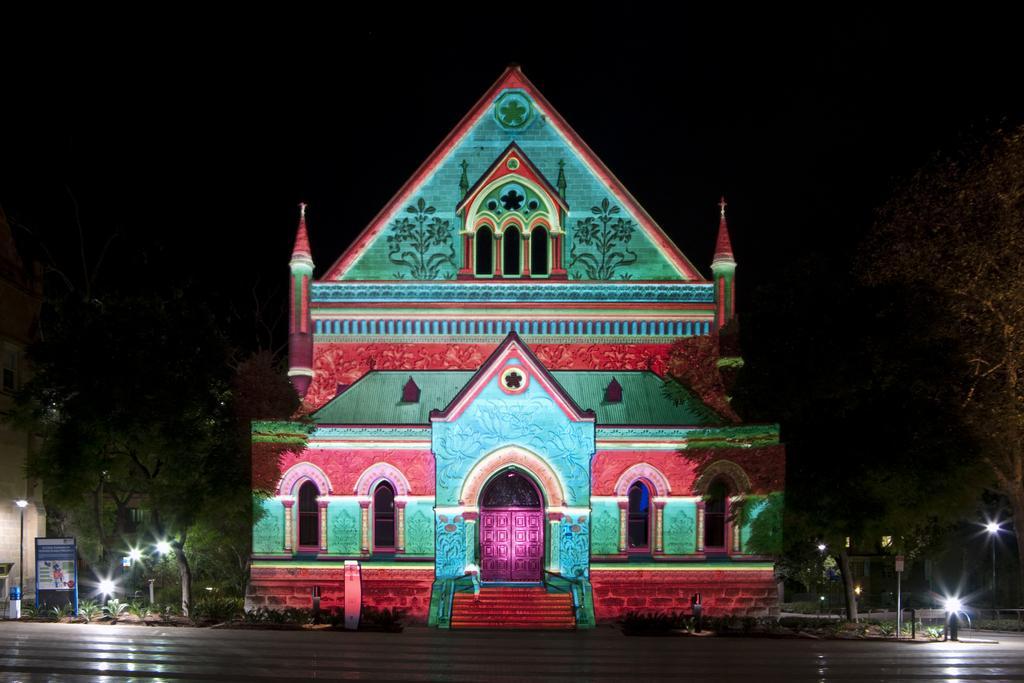How would you summarize this image in a sentence or two? There is a building with windows, doors, arches and steps. On the sides of the building there are trees and lights. On the left side there is a board. In the background it is dark. 